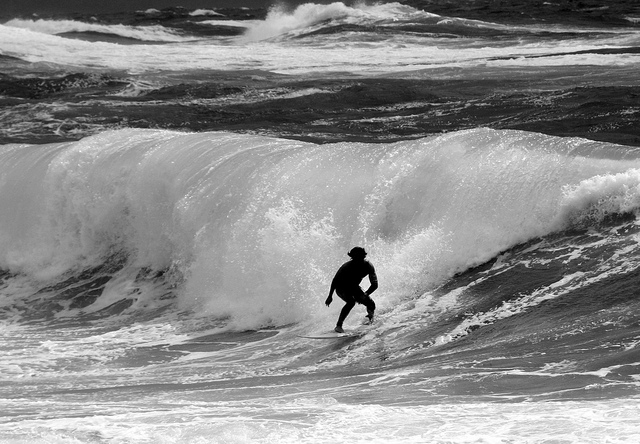What kind of surfboard is being used? It appears to be a shortboard, characterized by its pointed nose and length usually in the range of 5 to 7 feet - a popular choice for high-performance surfing and maneuverability in large waves. 